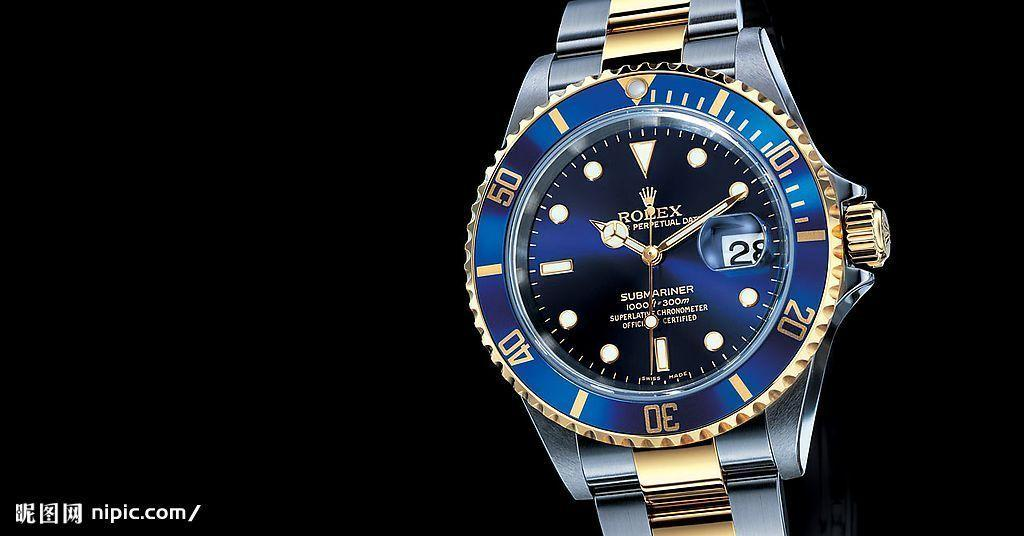<image>
Provide a brief description of the given image. A Rolex watch with a blue face shows the time as 10:10. 